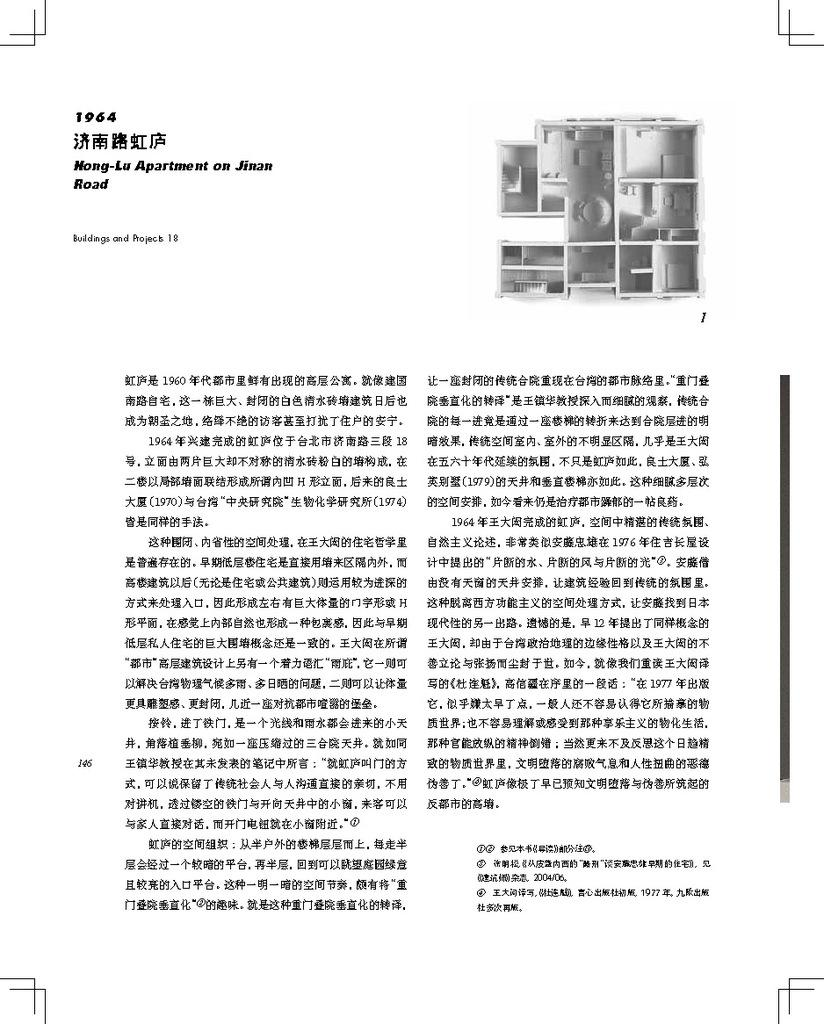<image>
Describe the image concisely. Document in Chinese that has in the upper left corner 1964 